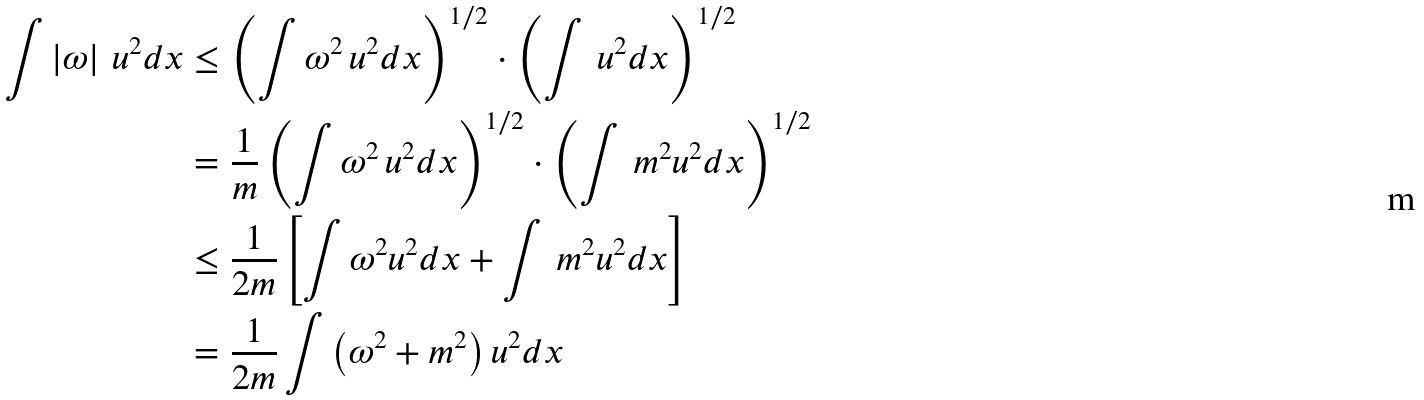<formula> <loc_0><loc_0><loc_500><loc_500>\int \left | \omega \right | \, u ^ { 2 } d x & \leq \left ( \int \omega ^ { 2 } \, u ^ { 2 } d x \right ) ^ { 1 / 2 } \cdot \left ( \int \, u ^ { 2 } d x \right ) ^ { 1 / 2 } \\ & = \frac { 1 } { m } \left ( \int \omega ^ { 2 } \, u ^ { 2 } d x \right ) ^ { 1 / 2 } \cdot \left ( \int \, m ^ { 2 } u ^ { 2 } d x \right ) ^ { 1 / 2 } \\ & \leq \frac { 1 } { 2 m } \left [ \int \omega ^ { 2 } u ^ { 2 } d x + \int \, m ^ { 2 } u ^ { 2 } d x \right ] \\ & = \frac { 1 } { 2 m } \int \left ( \omega ^ { 2 } + m ^ { 2 } \right ) u ^ { 2 } d x</formula> 